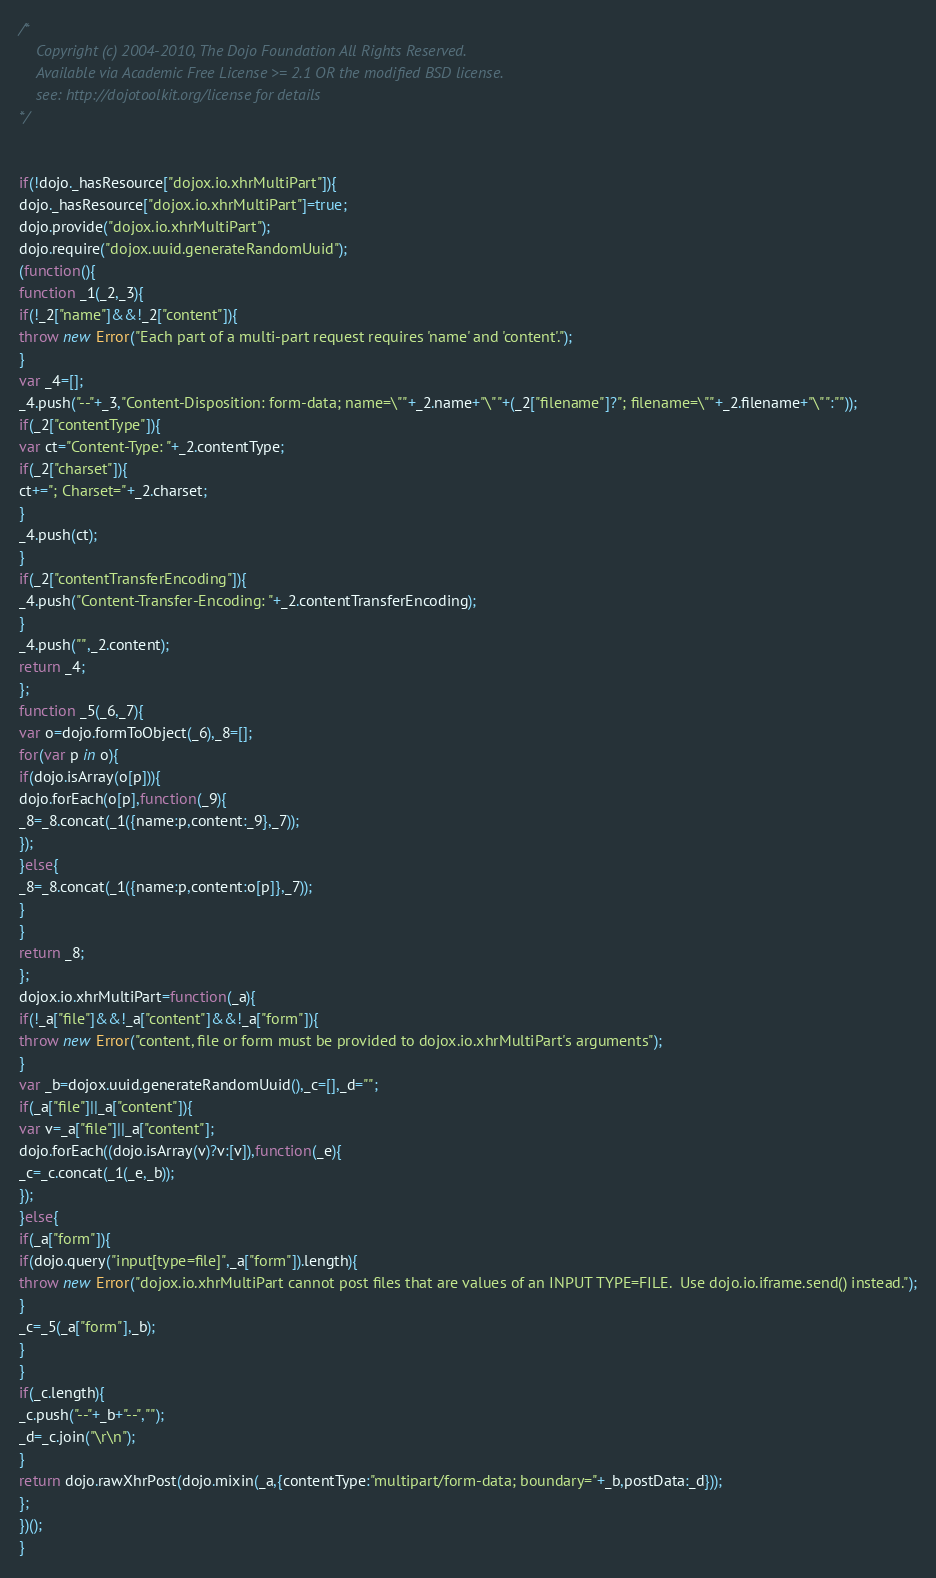<code> <loc_0><loc_0><loc_500><loc_500><_JavaScript_>/*
	Copyright (c) 2004-2010, The Dojo Foundation All Rights Reserved.
	Available via Academic Free License >= 2.1 OR the modified BSD license.
	see: http://dojotoolkit.org/license for details
*/


if(!dojo._hasResource["dojox.io.xhrMultiPart"]){
dojo._hasResource["dojox.io.xhrMultiPart"]=true;
dojo.provide("dojox.io.xhrMultiPart");
dojo.require("dojox.uuid.generateRandomUuid");
(function(){
function _1(_2,_3){
if(!_2["name"]&&!_2["content"]){
throw new Error("Each part of a multi-part request requires 'name' and 'content'.");
}
var _4=[];
_4.push("--"+_3,"Content-Disposition: form-data; name=\""+_2.name+"\""+(_2["filename"]?"; filename=\""+_2.filename+"\"":""));
if(_2["contentType"]){
var ct="Content-Type: "+_2.contentType;
if(_2["charset"]){
ct+="; Charset="+_2.charset;
}
_4.push(ct);
}
if(_2["contentTransferEncoding"]){
_4.push("Content-Transfer-Encoding: "+_2.contentTransferEncoding);
}
_4.push("",_2.content);
return _4;
};
function _5(_6,_7){
var o=dojo.formToObject(_6),_8=[];
for(var p in o){
if(dojo.isArray(o[p])){
dojo.forEach(o[p],function(_9){
_8=_8.concat(_1({name:p,content:_9},_7));
});
}else{
_8=_8.concat(_1({name:p,content:o[p]},_7));
}
}
return _8;
};
dojox.io.xhrMultiPart=function(_a){
if(!_a["file"]&&!_a["content"]&&!_a["form"]){
throw new Error("content, file or form must be provided to dojox.io.xhrMultiPart's arguments");
}
var _b=dojox.uuid.generateRandomUuid(),_c=[],_d="";
if(_a["file"]||_a["content"]){
var v=_a["file"]||_a["content"];
dojo.forEach((dojo.isArray(v)?v:[v]),function(_e){
_c=_c.concat(_1(_e,_b));
});
}else{
if(_a["form"]){
if(dojo.query("input[type=file]",_a["form"]).length){
throw new Error("dojox.io.xhrMultiPart cannot post files that are values of an INPUT TYPE=FILE.  Use dojo.io.iframe.send() instead.");
}
_c=_5(_a["form"],_b);
}
}
if(_c.length){
_c.push("--"+_b+"--","");
_d=_c.join("\r\n");
}
return dojo.rawXhrPost(dojo.mixin(_a,{contentType:"multipart/form-data; boundary="+_b,postData:_d}));
};
})();
}
</code> 